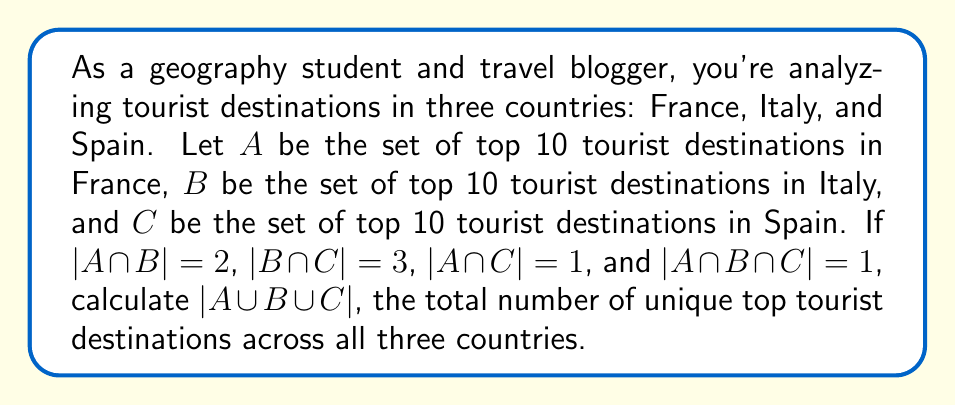Could you help me with this problem? Let's approach this step-by-step using set theory:

1) First, we need to understand what each intersection represents:
   $|A \cap B| = 2$ means 2 destinations are shared between France and Italy
   $|B \cap C| = 3$ means 3 destinations are shared between Italy and Spain
   $|A \cap C| = 1$ means 1 destination is shared between France and Spain
   $|A \cap B \cap C| = 1$ means 1 destination is shared by all three countries

2) We can use the principle of inclusion-exclusion to find $|A \cup B \cup C|$:

   $$|A \cup B \cup C| = |A| + |B| + |C| - |A \cap B| - |B \cap C| - |A \cap C| + |A \cap B \cap C|$$

3) We know that $|A| = |B| = |C| = 10$ (top 10 destinations for each country)

4) Substituting the known values:

   $$|A \cup B \cup C| = 10 + 10 + 10 - 2 - 3 - 1 + 1$$

5) Simplifying:
   
   $$|A \cup B \cup C| = 30 - 6 + 1 = 25$$

This result makes sense geographically. Out of 30 total destinations (10 for each country), 5 are shared between countries (2 + 3 + 1 - 1 to avoid double counting), leaving 25 unique destinations.
Answer: $|A \cup B \cup C| = 25$ 